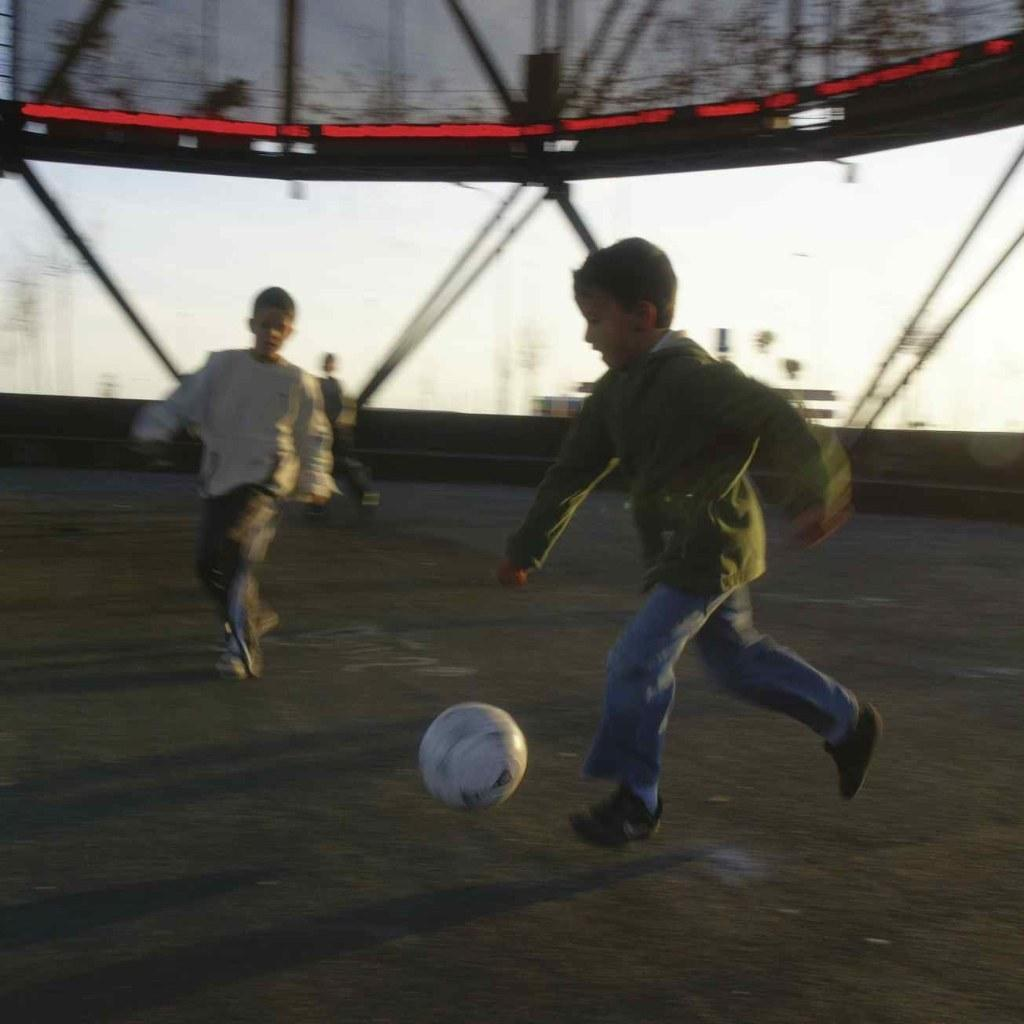What is the person in the image wearing? The person is wearing a green dress in the image. What is the person's position in the image? The person is in the air. What object is in front of the person? There is a ball in front of the person. How many other persons are beside the person in the air? There are two other persons beside the person in the air. What month is it in the image? The provided facts do not mention any specific month, so it cannot be determined from the image. What type of creature is flying beside the person in the air? There is no creature present in the image; only the three persons are visible. 